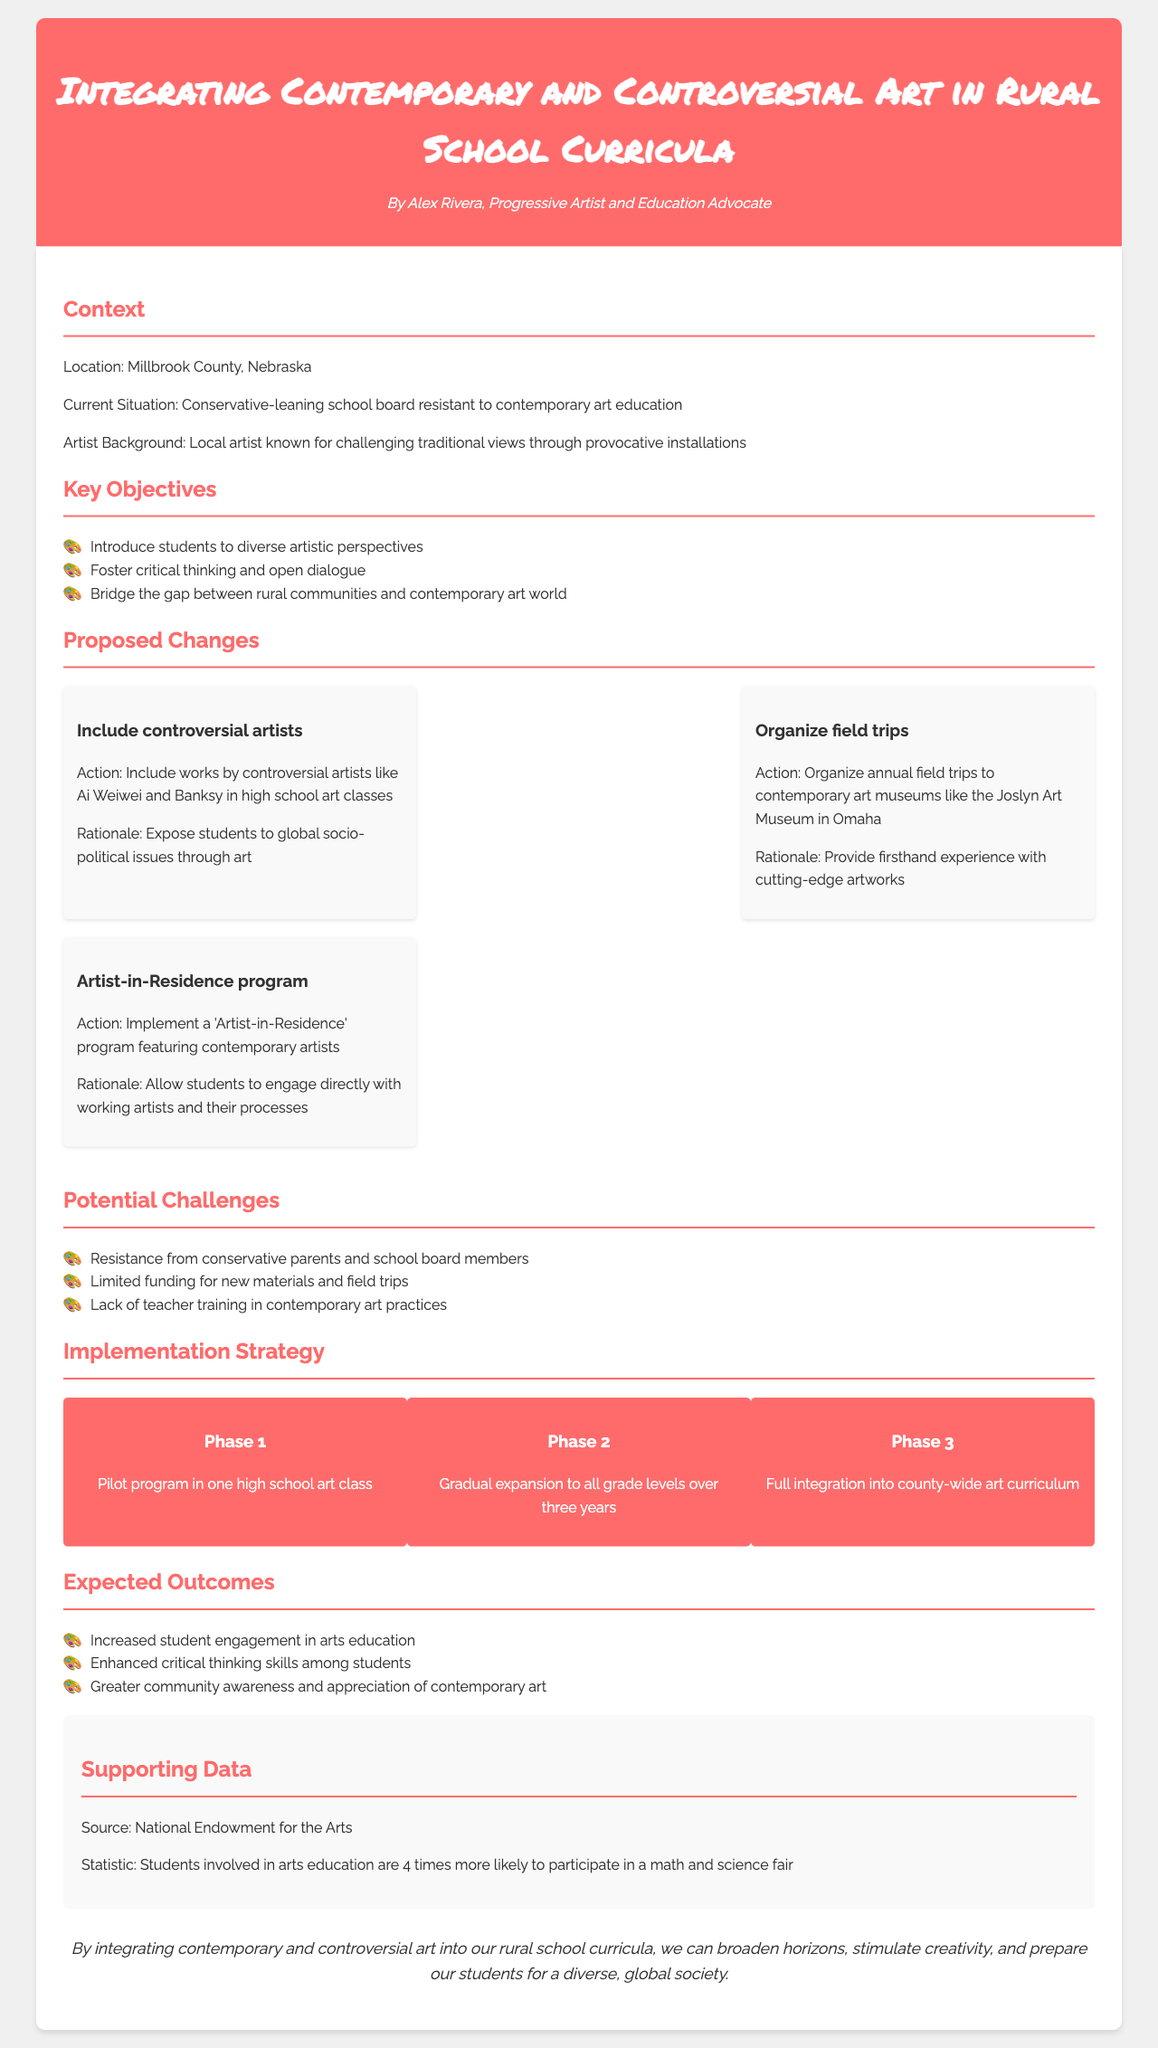What is the location of the proposed changes? The location of the proposed changes is mentioned at the beginning of the document as Millbrook County, Nebraska.
Answer: Millbrook County, Nebraska Who is the author of the document? The author of the document is identified at the top as Alex Rivera, Progressive Artist and Education Advocate.
Answer: Alex Rivera What is one of the key objectives? The key objectives section lists three specific objectives, and one of them is to introduce students to diverse artistic perspectives.
Answer: Introduce students to diverse artistic perspectives What is the rationale for including controversial artists? The rationale provided in the proposed changes section indicates that including works by controversial artists helps expose students to global socio-political issues through art.
Answer: Expose students to global socio-political issues through art What phase involves a pilot program? The implementation strategy indicates that Phase 1 focuses on piloting the program in one high school art class.
Answer: Phase 1 What statistic is provided in the supporting data? The document includes a statistic from the National Endowment for the Arts stating that students involved in arts education are four times more likely to participate in a math and science fair.
Answer: Four times more likely What are two potential challenges mentioned? The document lists potential challenges including resistance from conservative parents and limited funding for new materials and field trips.
Answer: Resistance from conservative parents, limited funding What is the last statement about integrating contemporary art? The conclusion of the document provides a final statement summarizing the benefits of integrating contemporary and controversial art into curricula, emphasizing broadening horizons and preparing students.
Answer: Broaden horizons, stimulate creativity, and prepare students for a diverse, global society 